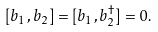<formula> <loc_0><loc_0><loc_500><loc_500>[ b _ { 1 } , b _ { 2 } ] = [ b _ { 1 } , b _ { 2 } ^ { \dagger } ] = 0 .</formula> 